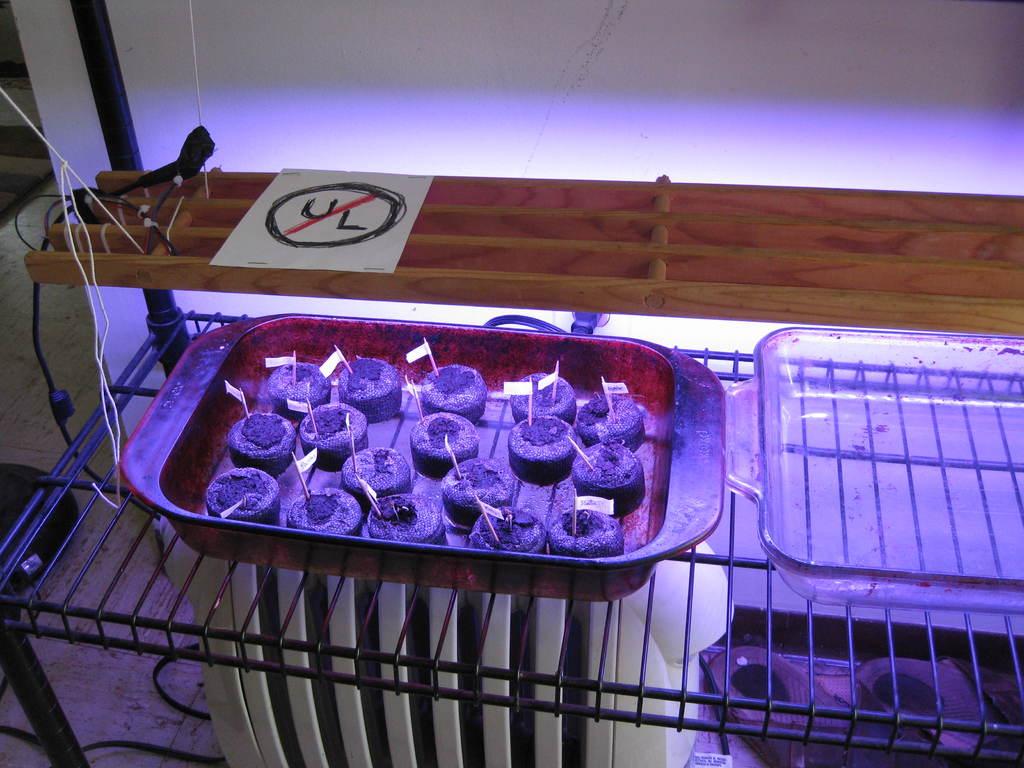What 2 letters are crossed out?
Provide a succinct answer. Ul. What color are the letters written in?
Provide a succinct answer. Black. 